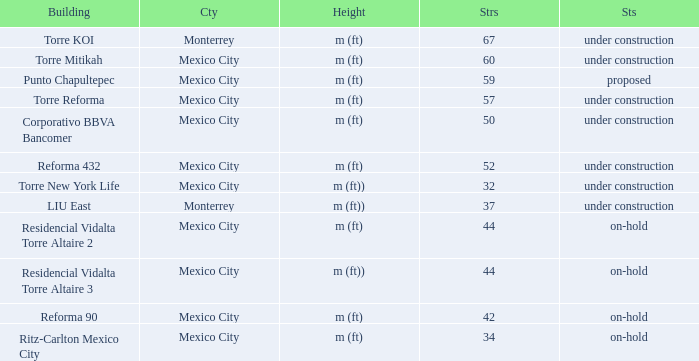What is the status of the torre reforma building that is over 44 stories in mexico city? Under construction. 